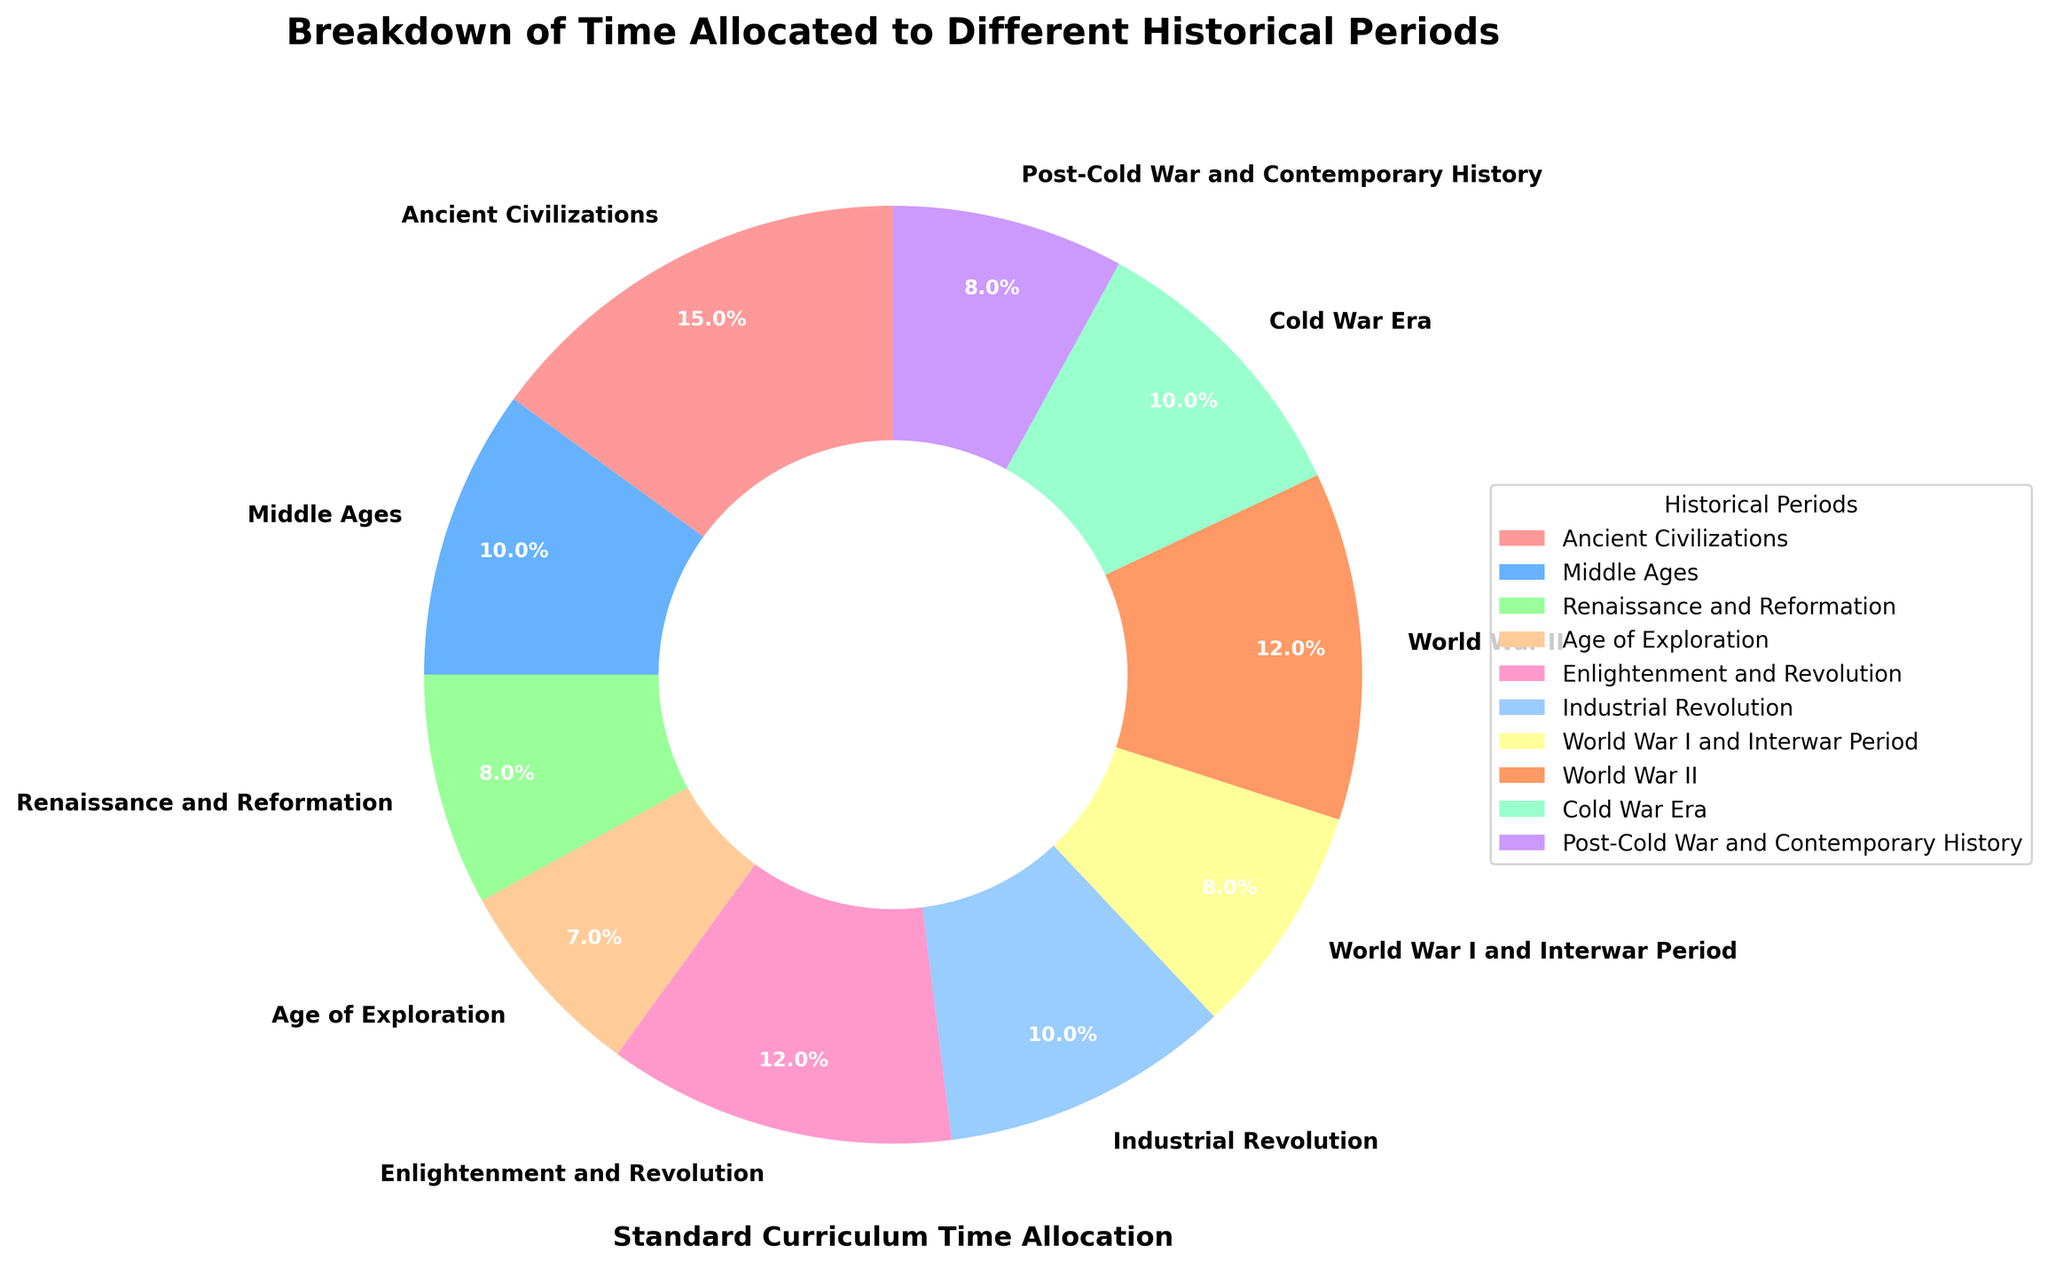What's the largest historical period by time allocated in the standard curriculum? The largest wedge in the pie chart should be identified and its label checked. The label "Ancient Civilizations" is associated with the highest percentage (15%).
Answer: Ancient Civilizations Which two periods have equal time allocated in the standard curriculum? Look for wedges with identical percentages. Both "Renaissance and Reformation" and "Post-Cold War and Contemporary History" have a percentage of 8%.
Answer: Renaissance and Reformation, Post-Cold War and Contemporary History What is the combined percentage of the Middle Ages and Industrial Revolution periods? Add the percentages of these two periods: Middle Ages (10%) + Industrial Revolution (10%) = 20%.
Answer: 20% Which historical period has less allocated time than the Age of Exploration but more than the Renaissance and Reformation? Compare percentages of all periods: Age of Exploration (7%) and Renaissance and Reformation (8%). "World War I and Interwar Period" and "Post-Cold War and Contemporary History" both meet these criteria with 8%.
Answer: World War I and Interwar Period, Post-Cold War and Contemporary History Are there more historical periods allocated with less than 10% of the time or with 10% or more? Count periods with percentages less than 10% (Renaissance and Reformation, Age of Exploration, World War I and Interwar Period, Post-Cold War and Contemporary History, totaling 4) and percentages of 10% or more (Ancient Civilizations, Middle Ages, Enlightenment and Revolution, Industrial Revolution, World War II, Cold War Era, totaling 6).
Answer: More What percentage of the total time is allocated to the periods from the World War I to the Cold War Era? Add percentages: World War I and Interwar Period (8%) + World War II (12%) + Cold War Era (10%) = 30%.
Answer: 30% Which periods have time allocations visually represented by shades of red? Check the wedges with shades of red in the pie chart. The periods "Ancient Civilizations" (15%) and "Enlightenment and Revolution" (12%) have red shades.
Answer: Ancient Civilizations, Enlightenment and Revolution What's the difference between the time allocated to Enlightenment and Revolution and the Cold War Era? Subtract percentages of the two periods: Enlightenment and Revolution (12%) - Cold War Era (10%) = 2%.
Answer: 2% Identify the least represented periods in the pie chart and their combined percentage. Locate the smallest wedges and sum their percentages: Age of Exploration (7%), which stands alone with no other smallest wedges, so the combined percentage is 7%.
Answer: 7% 